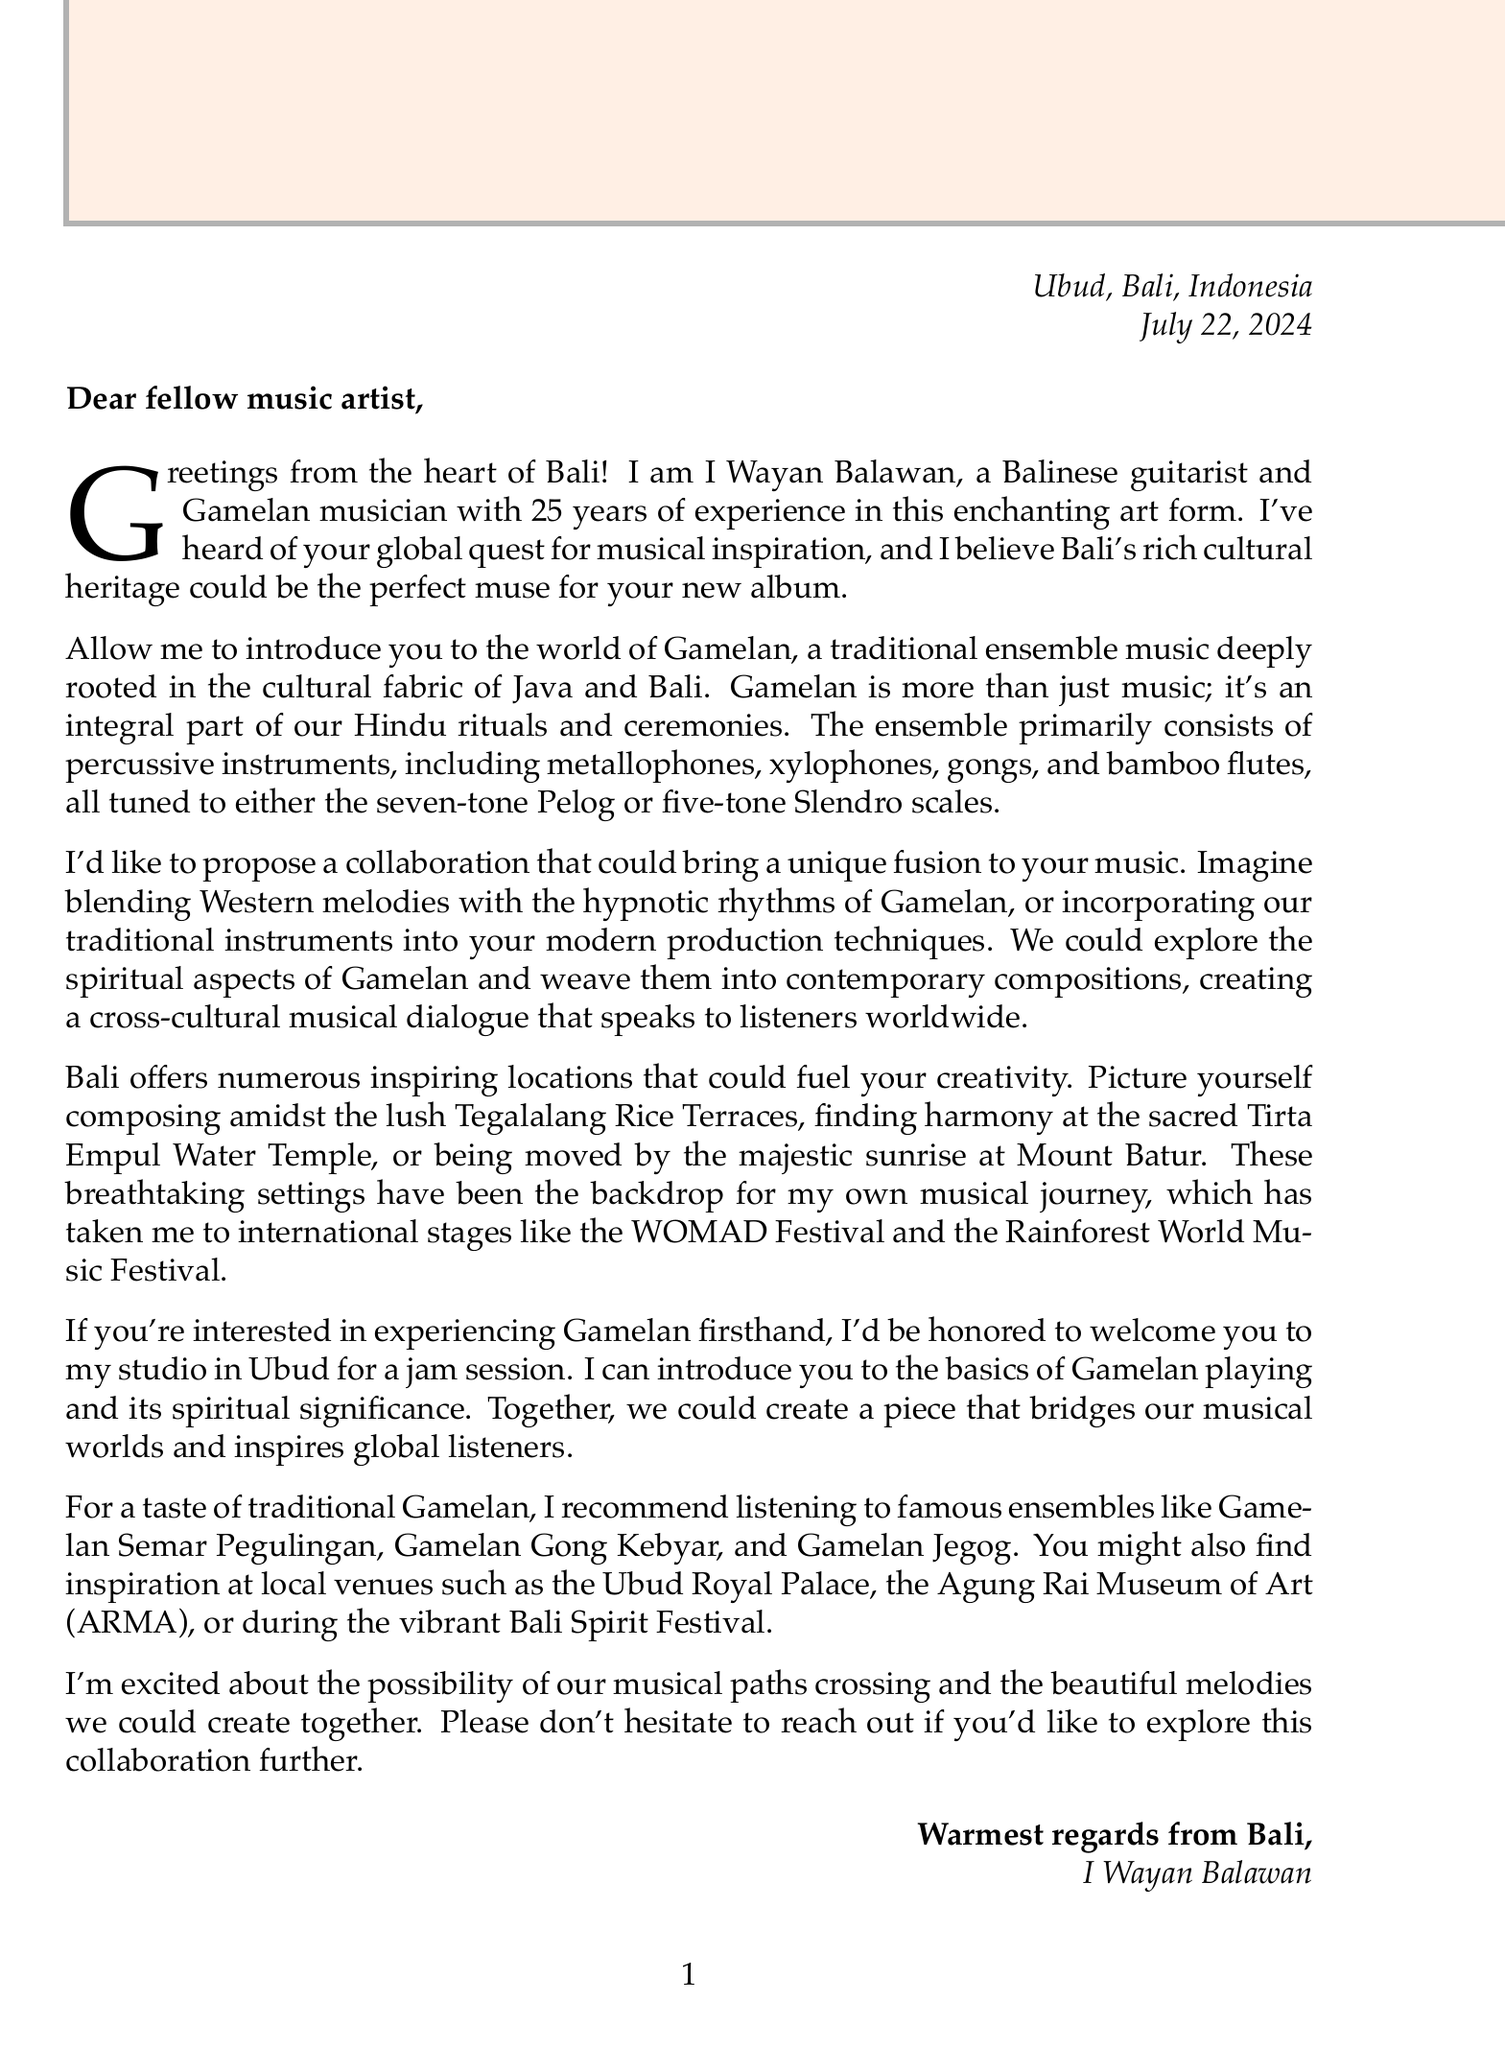What is the name of the sender? The sender introduces himself as I Wayan Balawan at the beginning of the letter.
Answer: I Wayan Balawan What is the main occupation of the sender? The sender states that he is a Balinese guitarist and Gamelan musician in the letter.
Answer: Balinese guitarist and Gamelan musician How many years of experience does the sender have? The sender mentions having 25 years of experience in the art form of Gamelan music.
Answer: 25 What are the two tuning systems mentioned in Gamelan music? The letter describes the tuning systems used in Gamelan music as Pelog and Slendro.
Answer: Pelog and Slendro What is one proposed idea for collaboration? The sender lists several collaboration ideas, one being the fusion of Western melodies with Gamelan rhythms.
Answer: Fusion of Western melodies with Gamelan rhythms What famous Gamelan ensemble is mentioned? The sender highlights several famous ensembles, including Gamelan Semar Pegulingan, as one of them.
Answer: Gamelan Semar Pegulingan What is the local venue mentioned for performance in Bali? The letter refers to local venues, specifically mentioning the Ubud Royal Palace.
Answer: Ubud Royal Palace What is the closing phrase of the letter? The letter concludes with a warm sentiment shared by the sender.
Answer: Warmest regards from Bali How does the sender suggest to experience Gamelan music? The sender invites the recipient to his studio in Ubud for a jam session to experience Gamelan music.
Answer: Jam session in Ubud 